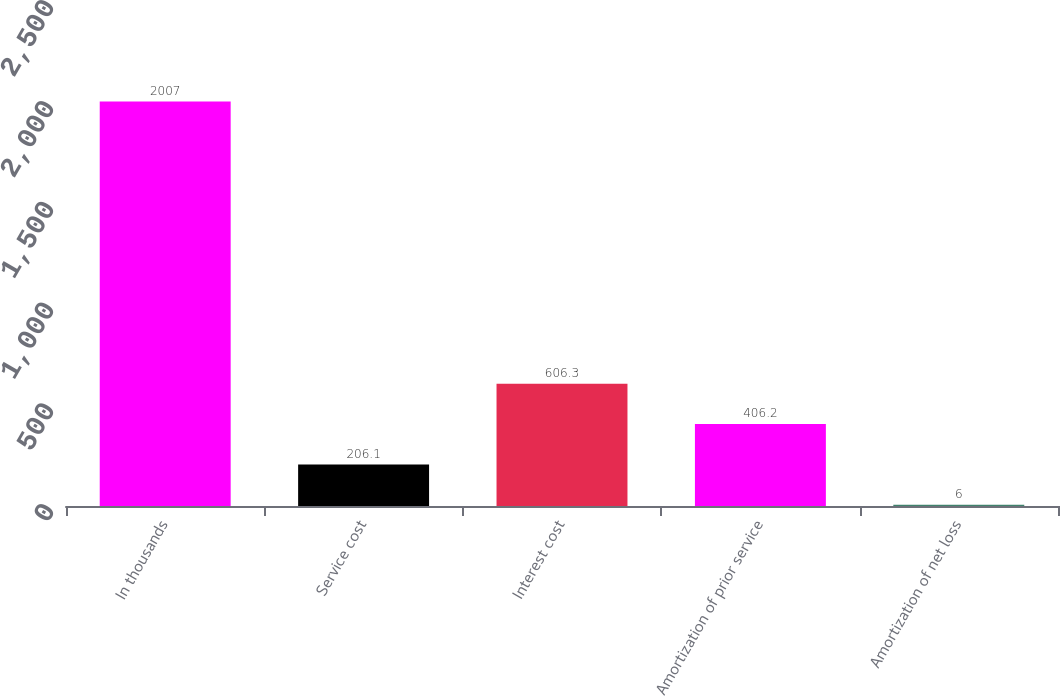Convert chart. <chart><loc_0><loc_0><loc_500><loc_500><bar_chart><fcel>In thousands<fcel>Service cost<fcel>Interest cost<fcel>Amortization of prior service<fcel>Amortization of net loss<nl><fcel>2007<fcel>206.1<fcel>606.3<fcel>406.2<fcel>6<nl></chart> 